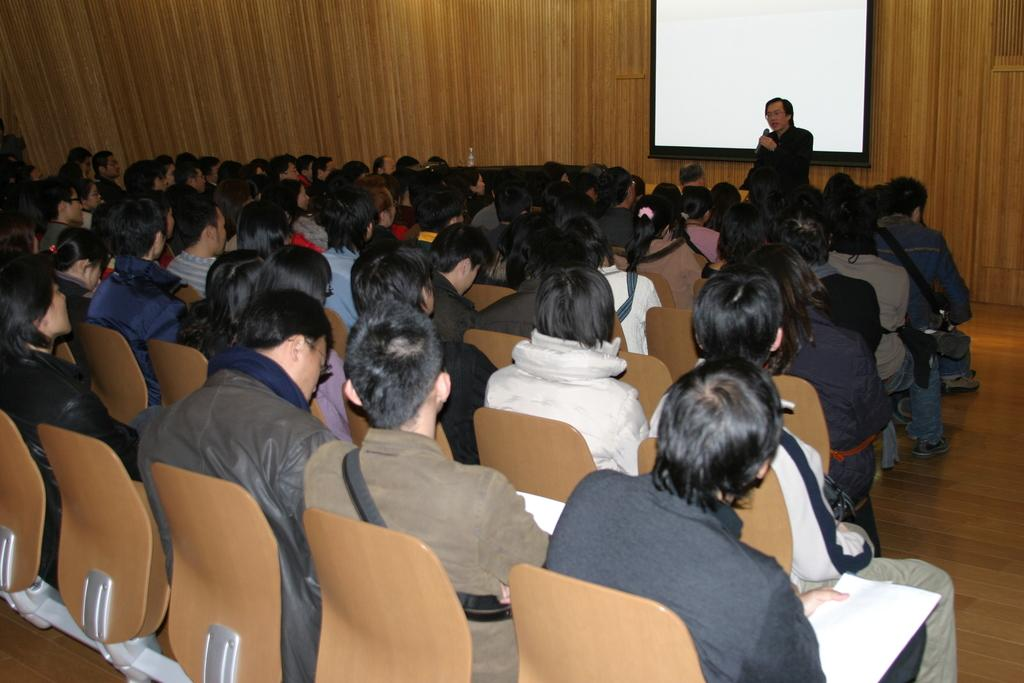What is the main subject of the image? The main subject of the image is a crowd. How are the people in the crowd positioned? The crowd is sitting on chairs. What is the person standing on the floor doing? The person is holding a microphone in his hand. What can be seen in the background of the image? There is a display and walls visible in the background. How many zebras are present in the image? There are no zebras present in the image. What is the mass of the crowd in the image? It is not possible to determine the mass of the crowd from the image alone. 